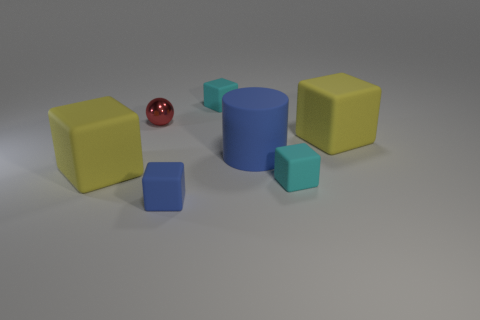There is a matte block that is behind the red metallic ball; is its color the same as the small block to the right of the matte cylinder?
Offer a terse response. Yes. Are there any other things that are made of the same material as the small red thing?
Offer a very short reply. No. Are there any other things that are the same shape as the shiny thing?
Your answer should be very brief. No. How many other objects are the same size as the sphere?
Offer a very short reply. 3. There is a thing that is to the left of the tiny red shiny thing; is it the same size as the yellow object that is to the right of the blue rubber cube?
Your answer should be compact. Yes. What number of things are either large cyan shiny spheres or yellow matte cubes that are on the right side of the tiny blue cube?
Your response must be concise. 1. How big is the cube behind the red metal sphere?
Your response must be concise. Small. Is the number of tiny matte things in front of the red metallic object less than the number of matte cylinders behind the matte cylinder?
Your answer should be compact. No. There is a tiny object that is both on the right side of the small blue matte block and behind the large blue rubber cylinder; what is it made of?
Your response must be concise. Rubber. What is the shape of the small red metal object left of the cyan object that is in front of the big matte cylinder?
Make the answer very short. Sphere. 